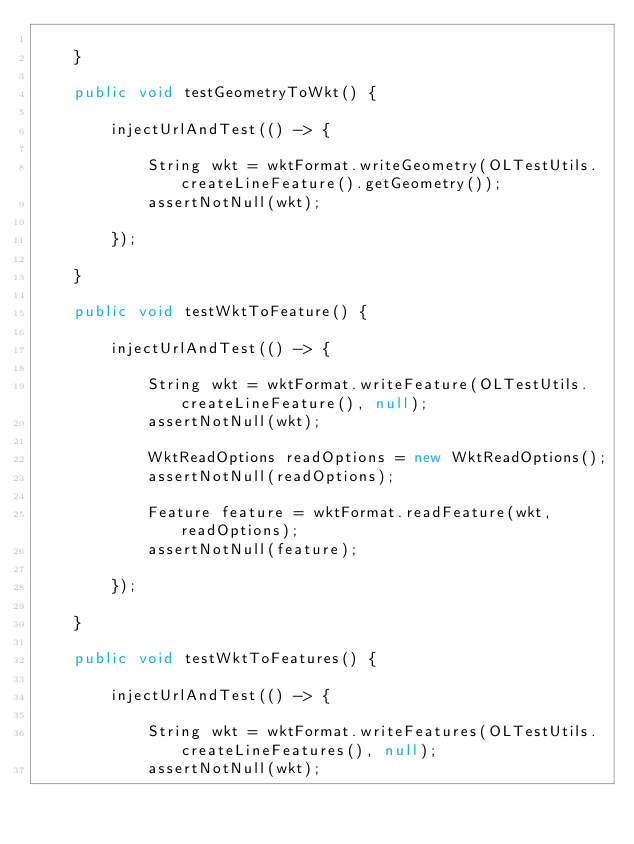<code> <loc_0><loc_0><loc_500><loc_500><_Java_>
    }

    public void testGeometryToWkt() {

        injectUrlAndTest(() -> {

            String wkt = wktFormat.writeGeometry(OLTestUtils.createLineFeature().getGeometry());
            assertNotNull(wkt);

        });

    }

    public void testWktToFeature() {

        injectUrlAndTest(() -> {

            String wkt = wktFormat.writeFeature(OLTestUtils.createLineFeature(), null);
            assertNotNull(wkt);

            WktReadOptions readOptions = new WktReadOptions();
            assertNotNull(readOptions);

            Feature feature = wktFormat.readFeature(wkt, readOptions);
            assertNotNull(feature);

        });

    }

    public void testWktToFeatures() {

        injectUrlAndTest(() -> {

            String wkt = wktFormat.writeFeatures(OLTestUtils.createLineFeatures(), null);
            assertNotNull(wkt);
</code> 